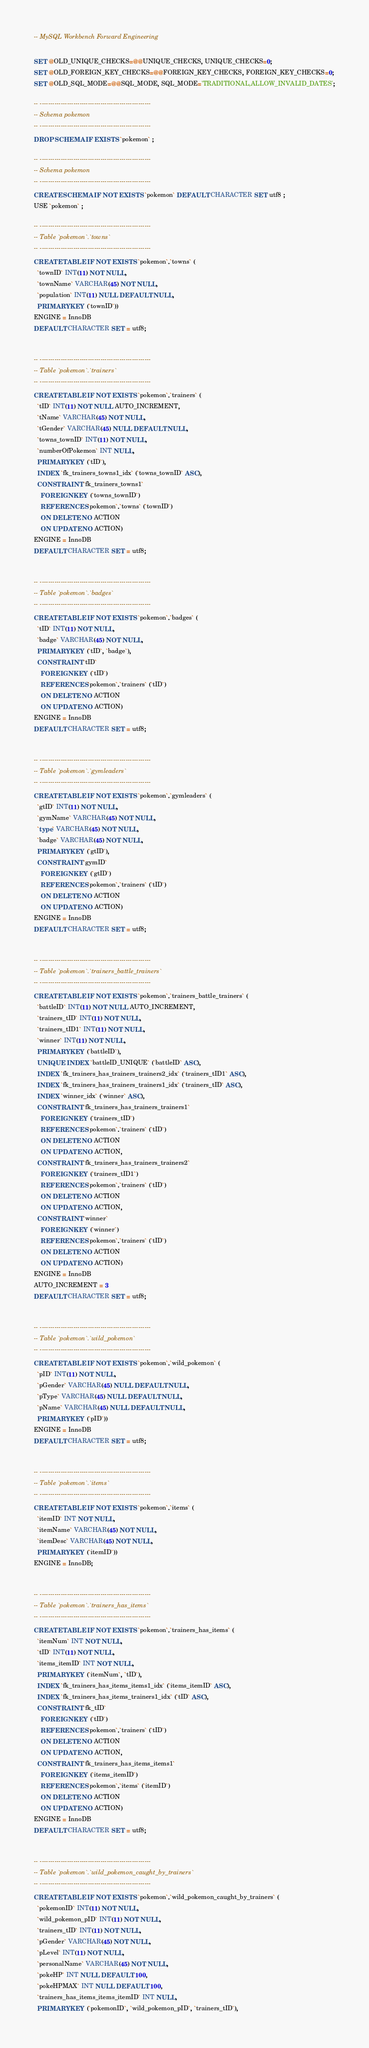Convert code to text. <code><loc_0><loc_0><loc_500><loc_500><_SQL_>-- MySQL Workbench Forward Engineering

SET @OLD_UNIQUE_CHECKS=@@UNIQUE_CHECKS, UNIQUE_CHECKS=0;
SET @OLD_FOREIGN_KEY_CHECKS=@@FOREIGN_KEY_CHECKS, FOREIGN_KEY_CHECKS=0;
SET @OLD_SQL_MODE=@@SQL_MODE, SQL_MODE='TRADITIONAL,ALLOW_INVALID_DATES';

-- -----------------------------------------------------
-- Schema pokemon
-- -----------------------------------------------------
DROP SCHEMA IF EXISTS `pokemon` ;

-- -----------------------------------------------------
-- Schema pokemon
-- -----------------------------------------------------
CREATE SCHEMA IF NOT EXISTS `pokemon` DEFAULT CHARACTER SET utf8 ;
USE `pokemon` ;

-- -----------------------------------------------------
-- Table `pokemon`.`towns`
-- -----------------------------------------------------
CREATE TABLE IF NOT EXISTS `pokemon`.`towns` (
  `townID` INT(11) NOT NULL,
  `townName` VARCHAR(45) NOT NULL,
  `population` INT(11) NULL DEFAULT NULL,
  PRIMARY KEY (`townID`))
ENGINE = InnoDB
DEFAULT CHARACTER SET = utf8;


-- -----------------------------------------------------
-- Table `pokemon`.`trainers`
-- -----------------------------------------------------
CREATE TABLE IF NOT EXISTS `pokemon`.`trainers` (
  `tID` INT(11) NOT NULL AUTO_INCREMENT,
  `tName` VARCHAR(45) NOT NULL,
  `tGender` VARCHAR(45) NULL DEFAULT NULL,
  `towns_townID` INT(11) NOT NULL,
  `numberOfPokemon` INT NULL,
  PRIMARY KEY (`tID`),
  INDEX `fk_trainers_towns1_idx` (`towns_townID` ASC),
  CONSTRAINT `fk_trainers_towns1`
    FOREIGN KEY (`towns_townID`)
    REFERENCES `pokemon`.`towns` (`townID`)
    ON DELETE NO ACTION
    ON UPDATE NO ACTION)
ENGINE = InnoDB
DEFAULT CHARACTER SET = utf8;


-- -----------------------------------------------------
-- Table `pokemon`.`badges`
-- -----------------------------------------------------
CREATE TABLE IF NOT EXISTS `pokemon`.`badges` (
  `tID` INT(11) NOT NULL,
  `badge` VARCHAR(45) NOT NULL,
  PRIMARY KEY (`tID`, `badge`),
  CONSTRAINT `tID`
    FOREIGN KEY (`tID`)
    REFERENCES `pokemon`.`trainers` (`tID`)
    ON DELETE NO ACTION
    ON UPDATE NO ACTION)
ENGINE = InnoDB
DEFAULT CHARACTER SET = utf8;


-- -----------------------------------------------------
-- Table `pokemon`.`gymleaders`
-- -----------------------------------------------------
CREATE TABLE IF NOT EXISTS `pokemon`.`gymleaders` (
  `gtID` INT(11) NOT NULL,
  `gymName` VARCHAR(45) NOT NULL,
  `type` VARCHAR(45) NOT NULL,
  `badge` VARCHAR(45) NOT NULL,
  PRIMARY KEY (`gtID`),
  CONSTRAINT `gymID`
    FOREIGN KEY (`gtID`)
    REFERENCES `pokemon`.`trainers` (`tID`)
    ON DELETE NO ACTION
    ON UPDATE NO ACTION)
ENGINE = InnoDB
DEFAULT CHARACTER SET = utf8;


-- -----------------------------------------------------
-- Table `pokemon`.`trainers_battle_trainers`
-- -----------------------------------------------------
CREATE TABLE IF NOT EXISTS `pokemon`.`trainers_battle_trainers` (
  `battleID` INT(11) NOT NULL AUTO_INCREMENT,
  `trainers_tID` INT(11) NOT NULL,
  `trainers_tID1` INT(11) NOT NULL,
  `winner` INT(11) NOT NULL,
  PRIMARY KEY (`battleID`),
  UNIQUE INDEX `battleID_UNIQUE` (`battleID` ASC),
  INDEX `fk_trainers_has_trainers_trainers2_idx` (`trainers_tID1` ASC),
  INDEX `fk_trainers_has_trainers_trainers1_idx` (`trainers_tID` ASC),
  INDEX `winner_idx` (`winner` ASC),
  CONSTRAINT `fk_trainers_has_trainers_trainers1`
    FOREIGN KEY (`trainers_tID`)
    REFERENCES `pokemon`.`trainers` (`tID`)
    ON DELETE NO ACTION
    ON UPDATE NO ACTION,
  CONSTRAINT `fk_trainers_has_trainers_trainers2`
    FOREIGN KEY (`trainers_tID1`)
    REFERENCES `pokemon`.`trainers` (`tID`)
    ON DELETE NO ACTION
    ON UPDATE NO ACTION,
  CONSTRAINT `winner`
    FOREIGN KEY (`winner`)
    REFERENCES `pokemon`.`trainers` (`tID`)
    ON DELETE NO ACTION
    ON UPDATE NO ACTION)
ENGINE = InnoDB
AUTO_INCREMENT = 3
DEFAULT CHARACTER SET = utf8;


-- -----------------------------------------------------
-- Table `pokemon`.`wild_pokemon`
-- -----------------------------------------------------
CREATE TABLE IF NOT EXISTS `pokemon`.`wild_pokemon` (
  `pID` INT(11) NOT NULL,
  `pGender` VARCHAR(45) NULL DEFAULT NULL,
  `pType` VARCHAR(45) NULL DEFAULT NULL,
  `pName` VARCHAR(45) NULL DEFAULT NULL,
  PRIMARY KEY (`pID`))
ENGINE = InnoDB
DEFAULT CHARACTER SET = utf8;


-- -----------------------------------------------------
-- Table `pokemon`.`items`
-- -----------------------------------------------------
CREATE TABLE IF NOT EXISTS `pokemon`.`items` (
  `itemID` INT NOT NULL,
  `itemName` VARCHAR(45) NOT NULL,
  `itemDesc` VARCHAR(45) NOT NULL,
  PRIMARY KEY (`itemID`))
ENGINE = InnoDB;


-- -----------------------------------------------------
-- Table `pokemon`.`trainers_has_items`
-- -----------------------------------------------------
CREATE TABLE IF NOT EXISTS `pokemon`.`trainers_has_items` (
  `itemNum` INT NOT NULL,
  `tID` INT(11) NOT NULL,
  `items_itemID` INT NOT NULL,
  PRIMARY KEY (`itemNum`, `tID`),
  INDEX `fk_trainers_has_items_items1_idx` (`items_itemID` ASC),
  INDEX `fk_trainers_has_items_trainers1_idx` (`tID` ASC),
  CONSTRAINT `fk_tID`
    FOREIGN KEY (`tID`)
    REFERENCES `pokemon`.`trainers` (`tID`)
    ON DELETE NO ACTION
    ON UPDATE NO ACTION,
  CONSTRAINT `fk_trainers_has_items_items1`
    FOREIGN KEY (`items_itemID`)
    REFERENCES `pokemon`.`items` (`itemID`)
    ON DELETE NO ACTION
    ON UPDATE NO ACTION)
ENGINE = InnoDB
DEFAULT CHARACTER SET = utf8;


-- -----------------------------------------------------
-- Table `pokemon`.`wild_pokemon_caught_by_trainers`
-- -----------------------------------------------------
CREATE TABLE IF NOT EXISTS `pokemon`.`wild_pokemon_caught_by_trainers` (
  `pokemonID` INT(11) NOT NULL,
  `wild_pokemon_pID` INT(11) NOT NULL,
  `trainers_tID` INT(11) NOT NULL,
  `pGender` VARCHAR(45) NOT NULL,
  `pLevel` INT(11) NOT NULL,
  `personalName` VARCHAR(45) NOT NULL,
  `pokeHP` INT NULL DEFAULT 100,
  `pokeHPMAX` INT NULL DEFAULT 100,
  `trainers_has_items_items_itemID` INT NULL,
  PRIMARY KEY (`pokemonID`, `wild_pokemon_pID`, `trainers_tID`),</code> 